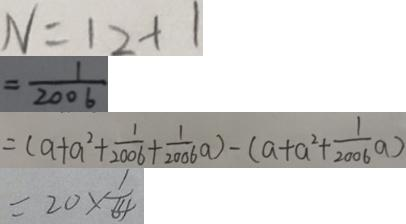<formula> <loc_0><loc_0><loc_500><loc_500>N = 1 2 + 1 
 = \frac { 1 } { 2 0 0 6 } 
 = ( a + a ^ { 2 } + \frac { 1 } { 2 0 0 6 } + \frac { 1 } { 2 0 0 6 } a ) - ( a + a ^ { 2 } + \frac { 1 } { 2 0 0 6 } a ) 
 = 2 0 \times \frac { 1 } { 6 4 }</formula> 